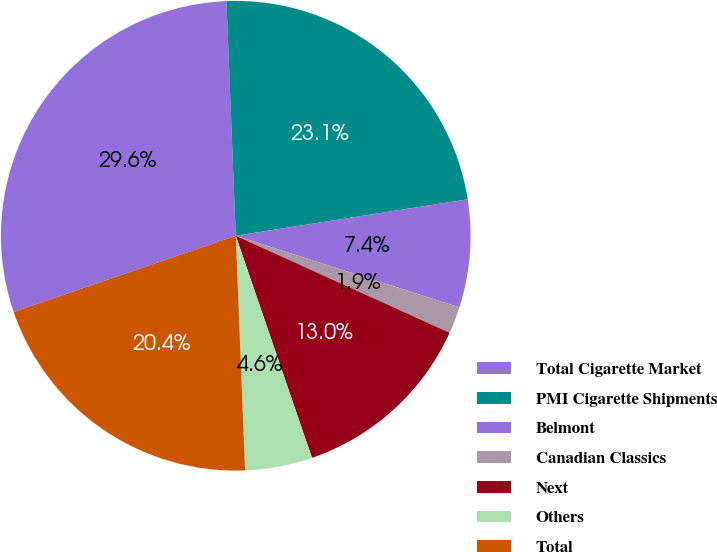Convert chart to OTSL. <chart><loc_0><loc_0><loc_500><loc_500><pie_chart><fcel>Total Cigarette Market<fcel>PMI Cigarette Shipments<fcel>Belmont<fcel>Canadian Classics<fcel>Next<fcel>Others<fcel>Total<nl><fcel>29.63%<fcel>23.15%<fcel>7.41%<fcel>1.85%<fcel>12.96%<fcel>4.63%<fcel>20.37%<nl></chart> 